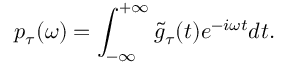<formula> <loc_0><loc_0><loc_500><loc_500>p _ { \tau } ( \omega ) = \int _ { - \infty } ^ { + \infty } \tilde { g } _ { \tau } ( t ) e ^ { - i \omega t } d t .</formula> 